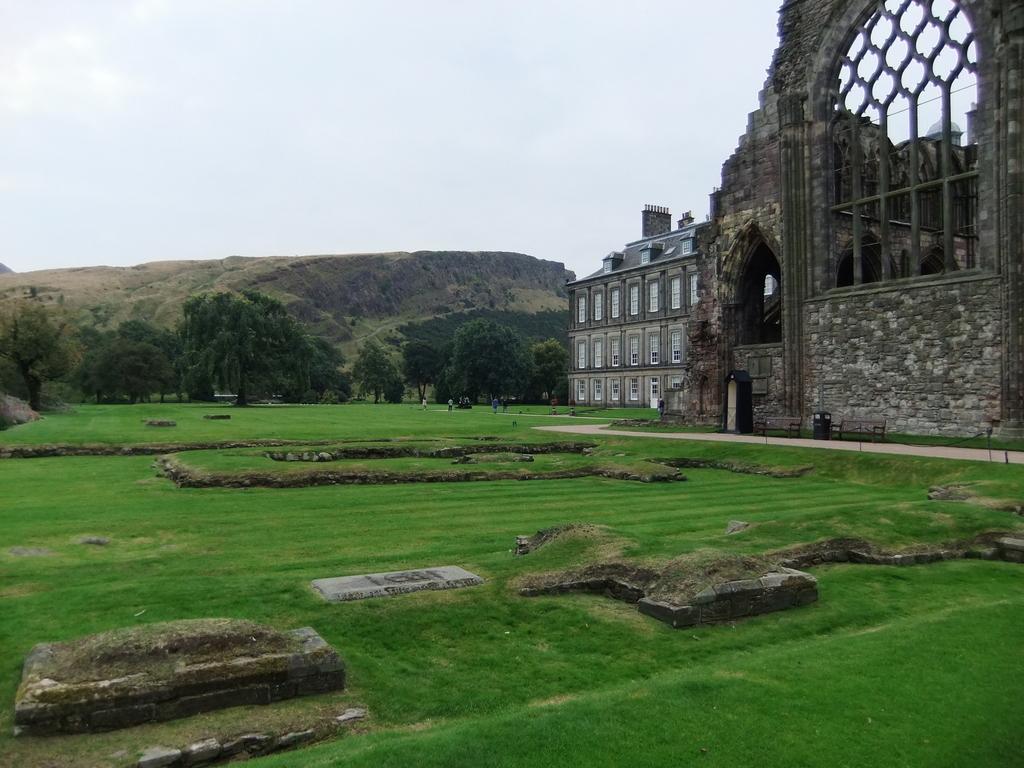How would you summarize this image in a sentence or two? In the foreground, I can see grass, buildings, bench, windows and a group of people. In the background, I can see trees, mountains and the sky. This image taken, maybe during a day. 